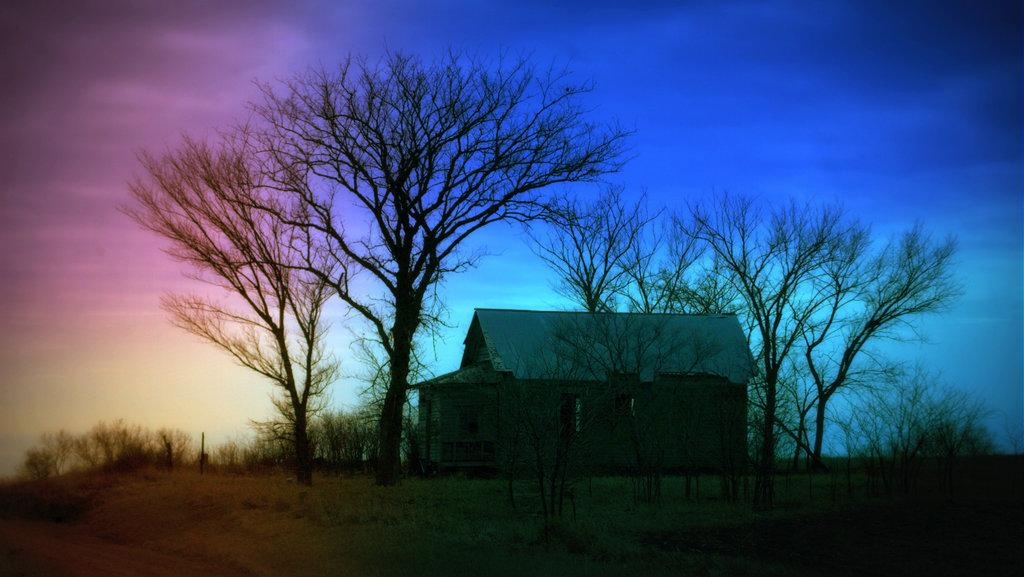What type of natural elements can be seen in the image? There are many trees in the image. What type of structure is present in the image? There is a house in the image. What can be seen in the background of the image? There is a colorful sky visible in the background of the image. What type of mouth can be seen on the trees in the image? There are no mouths present on the trees in the image. Is there a gun visible in the image? No, there is no gun present in the image. 